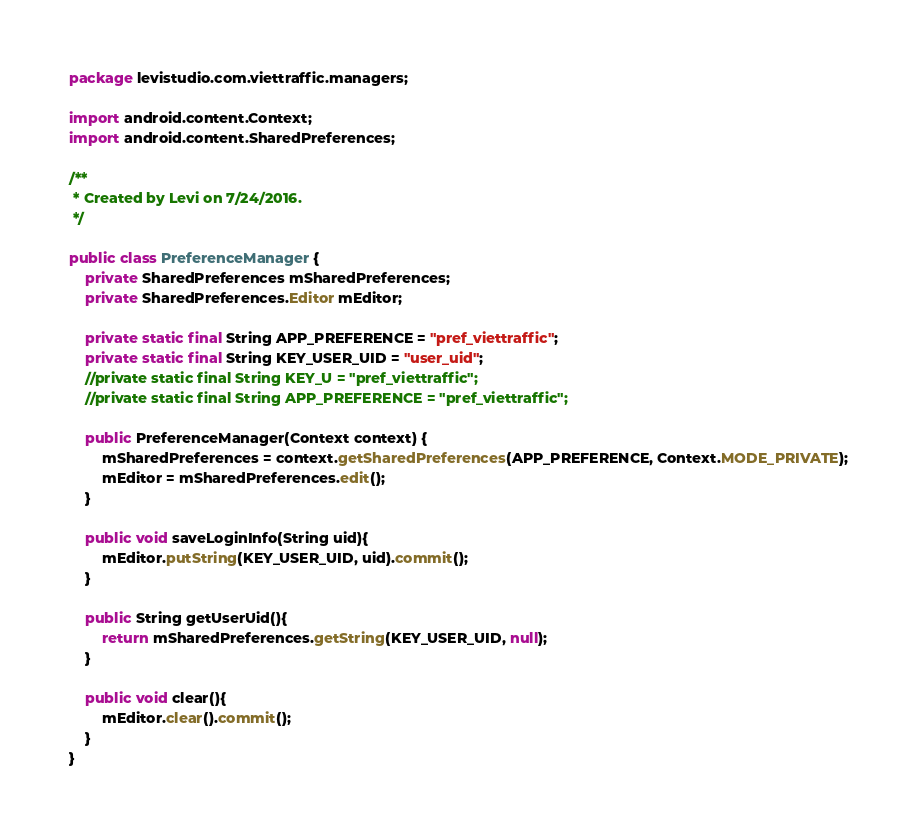Convert code to text. <code><loc_0><loc_0><loc_500><loc_500><_Java_>package levistudio.com.viettraffic.managers;

import android.content.Context;
import android.content.SharedPreferences;

/**
 * Created by Levi on 7/24/2016.
 */

public class PreferenceManager {
    private SharedPreferences mSharedPreferences;
    private SharedPreferences.Editor mEditor;

    private static final String APP_PREFERENCE = "pref_viettraffic";
    private static final String KEY_USER_UID = "user_uid";
    //private static final String KEY_U = "pref_viettraffic";
    //private static final String APP_PREFERENCE = "pref_viettraffic";

    public PreferenceManager(Context context) {
        mSharedPreferences = context.getSharedPreferences(APP_PREFERENCE, Context.MODE_PRIVATE);
        mEditor = mSharedPreferences.edit();
    }

    public void saveLoginInfo(String uid){
        mEditor.putString(KEY_USER_UID, uid).commit();
    }

    public String getUserUid(){
        return mSharedPreferences.getString(KEY_USER_UID, null);
    }

    public void clear(){
        mEditor.clear().commit();
    }
}
</code> 